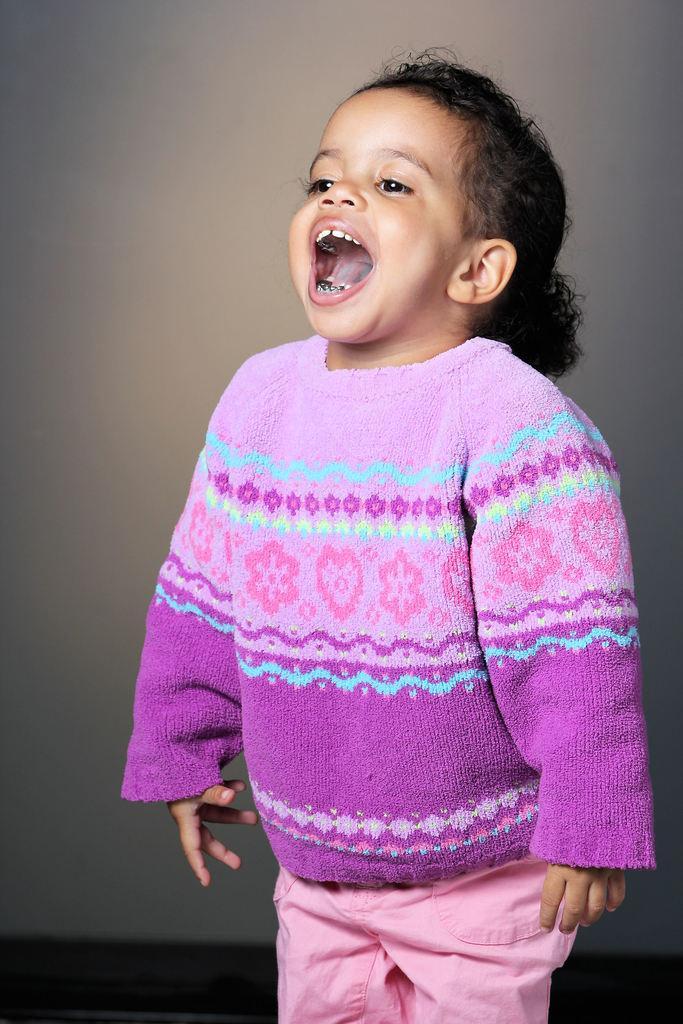Please provide a concise description of this image. In this image in the center there is a kid standing and smiling. 